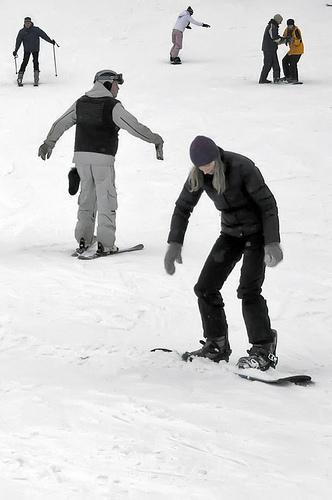What skill level do most snowboarders here have? Please explain your reasoning. beginners. The people look like they don't know much about the sport. 